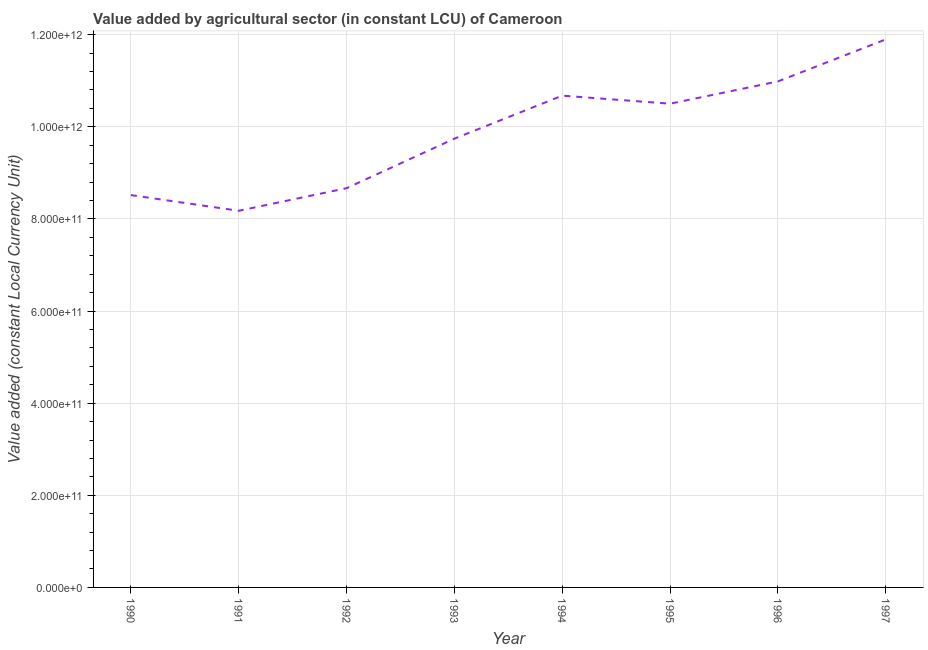What is the value added by agriculture sector in 1993?
Offer a terse response. 9.74e+11. Across all years, what is the maximum value added by agriculture sector?
Your answer should be very brief. 1.19e+12. Across all years, what is the minimum value added by agriculture sector?
Provide a short and direct response. 8.18e+11. In which year was the value added by agriculture sector maximum?
Provide a short and direct response. 1997. What is the sum of the value added by agriculture sector?
Your answer should be compact. 7.92e+12. What is the difference between the value added by agriculture sector in 1995 and 1997?
Keep it short and to the point. -1.40e+11. What is the average value added by agriculture sector per year?
Offer a terse response. 9.89e+11. What is the median value added by agriculture sector?
Your answer should be very brief. 1.01e+12. In how many years, is the value added by agriculture sector greater than 120000000000 LCU?
Ensure brevity in your answer.  8. What is the ratio of the value added by agriculture sector in 1990 to that in 1996?
Keep it short and to the point. 0.78. What is the difference between the highest and the second highest value added by agriculture sector?
Ensure brevity in your answer.  9.12e+1. Is the sum of the value added by agriculture sector in 1996 and 1997 greater than the maximum value added by agriculture sector across all years?
Give a very brief answer. Yes. What is the difference between the highest and the lowest value added by agriculture sector?
Offer a terse response. 3.72e+11. In how many years, is the value added by agriculture sector greater than the average value added by agriculture sector taken over all years?
Give a very brief answer. 4. How many lines are there?
Offer a terse response. 1. How many years are there in the graph?
Offer a very short reply. 8. What is the difference between two consecutive major ticks on the Y-axis?
Your response must be concise. 2.00e+11. Does the graph contain any zero values?
Offer a very short reply. No. Does the graph contain grids?
Give a very brief answer. Yes. What is the title of the graph?
Keep it short and to the point. Value added by agricultural sector (in constant LCU) of Cameroon. What is the label or title of the X-axis?
Your answer should be very brief. Year. What is the label or title of the Y-axis?
Keep it short and to the point. Value added (constant Local Currency Unit). What is the Value added (constant Local Currency Unit) in 1990?
Provide a short and direct response. 8.52e+11. What is the Value added (constant Local Currency Unit) of 1991?
Ensure brevity in your answer.  8.18e+11. What is the Value added (constant Local Currency Unit) of 1992?
Your response must be concise. 8.67e+11. What is the Value added (constant Local Currency Unit) in 1993?
Offer a terse response. 9.74e+11. What is the Value added (constant Local Currency Unit) of 1994?
Provide a succinct answer. 1.07e+12. What is the Value added (constant Local Currency Unit) in 1995?
Make the answer very short. 1.05e+12. What is the Value added (constant Local Currency Unit) of 1996?
Offer a terse response. 1.10e+12. What is the Value added (constant Local Currency Unit) of 1997?
Offer a terse response. 1.19e+12. What is the difference between the Value added (constant Local Currency Unit) in 1990 and 1991?
Give a very brief answer. 3.41e+1. What is the difference between the Value added (constant Local Currency Unit) in 1990 and 1992?
Make the answer very short. -1.50e+1. What is the difference between the Value added (constant Local Currency Unit) in 1990 and 1993?
Make the answer very short. -1.23e+11. What is the difference between the Value added (constant Local Currency Unit) in 1990 and 1994?
Provide a succinct answer. -2.16e+11. What is the difference between the Value added (constant Local Currency Unit) in 1990 and 1995?
Make the answer very short. -1.98e+11. What is the difference between the Value added (constant Local Currency Unit) in 1990 and 1996?
Offer a very short reply. -2.47e+11. What is the difference between the Value added (constant Local Currency Unit) in 1990 and 1997?
Your response must be concise. -3.38e+11. What is the difference between the Value added (constant Local Currency Unit) in 1991 and 1992?
Provide a succinct answer. -4.91e+1. What is the difference between the Value added (constant Local Currency Unit) in 1991 and 1993?
Make the answer very short. -1.57e+11. What is the difference between the Value added (constant Local Currency Unit) in 1991 and 1994?
Make the answer very short. -2.50e+11. What is the difference between the Value added (constant Local Currency Unit) in 1991 and 1995?
Your answer should be very brief. -2.32e+11. What is the difference between the Value added (constant Local Currency Unit) in 1991 and 1996?
Your answer should be compact. -2.81e+11. What is the difference between the Value added (constant Local Currency Unit) in 1991 and 1997?
Your response must be concise. -3.72e+11. What is the difference between the Value added (constant Local Currency Unit) in 1992 and 1993?
Make the answer very short. -1.08e+11. What is the difference between the Value added (constant Local Currency Unit) in 1992 and 1994?
Make the answer very short. -2.01e+11. What is the difference between the Value added (constant Local Currency Unit) in 1992 and 1995?
Provide a short and direct response. -1.83e+11. What is the difference between the Value added (constant Local Currency Unit) in 1992 and 1996?
Make the answer very short. -2.32e+11. What is the difference between the Value added (constant Local Currency Unit) in 1992 and 1997?
Your answer should be very brief. -3.23e+11. What is the difference between the Value added (constant Local Currency Unit) in 1993 and 1994?
Your answer should be compact. -9.33e+1. What is the difference between the Value added (constant Local Currency Unit) in 1993 and 1995?
Your response must be concise. -7.59e+1. What is the difference between the Value added (constant Local Currency Unit) in 1993 and 1996?
Ensure brevity in your answer.  -1.24e+11. What is the difference between the Value added (constant Local Currency Unit) in 1993 and 1997?
Offer a terse response. -2.15e+11. What is the difference between the Value added (constant Local Currency Unit) in 1994 and 1995?
Your response must be concise. 1.75e+1. What is the difference between the Value added (constant Local Currency Unit) in 1994 and 1996?
Make the answer very short. -3.09e+1. What is the difference between the Value added (constant Local Currency Unit) in 1994 and 1997?
Provide a short and direct response. -1.22e+11. What is the difference between the Value added (constant Local Currency Unit) in 1995 and 1996?
Provide a short and direct response. -4.84e+1. What is the difference between the Value added (constant Local Currency Unit) in 1995 and 1997?
Give a very brief answer. -1.40e+11. What is the difference between the Value added (constant Local Currency Unit) in 1996 and 1997?
Your answer should be very brief. -9.12e+1. What is the ratio of the Value added (constant Local Currency Unit) in 1990 to that in 1991?
Your response must be concise. 1.04. What is the ratio of the Value added (constant Local Currency Unit) in 1990 to that in 1992?
Offer a terse response. 0.98. What is the ratio of the Value added (constant Local Currency Unit) in 1990 to that in 1993?
Your response must be concise. 0.87. What is the ratio of the Value added (constant Local Currency Unit) in 1990 to that in 1994?
Give a very brief answer. 0.8. What is the ratio of the Value added (constant Local Currency Unit) in 1990 to that in 1995?
Offer a terse response. 0.81. What is the ratio of the Value added (constant Local Currency Unit) in 1990 to that in 1996?
Offer a terse response. 0.78. What is the ratio of the Value added (constant Local Currency Unit) in 1990 to that in 1997?
Give a very brief answer. 0.72. What is the ratio of the Value added (constant Local Currency Unit) in 1991 to that in 1992?
Your answer should be compact. 0.94. What is the ratio of the Value added (constant Local Currency Unit) in 1991 to that in 1993?
Offer a terse response. 0.84. What is the ratio of the Value added (constant Local Currency Unit) in 1991 to that in 1994?
Your answer should be very brief. 0.77. What is the ratio of the Value added (constant Local Currency Unit) in 1991 to that in 1995?
Make the answer very short. 0.78. What is the ratio of the Value added (constant Local Currency Unit) in 1991 to that in 1996?
Provide a short and direct response. 0.74. What is the ratio of the Value added (constant Local Currency Unit) in 1991 to that in 1997?
Make the answer very short. 0.69. What is the ratio of the Value added (constant Local Currency Unit) in 1992 to that in 1993?
Keep it short and to the point. 0.89. What is the ratio of the Value added (constant Local Currency Unit) in 1992 to that in 1994?
Provide a short and direct response. 0.81. What is the ratio of the Value added (constant Local Currency Unit) in 1992 to that in 1995?
Ensure brevity in your answer.  0.82. What is the ratio of the Value added (constant Local Currency Unit) in 1992 to that in 1996?
Keep it short and to the point. 0.79. What is the ratio of the Value added (constant Local Currency Unit) in 1992 to that in 1997?
Ensure brevity in your answer.  0.73. What is the ratio of the Value added (constant Local Currency Unit) in 1993 to that in 1995?
Provide a succinct answer. 0.93. What is the ratio of the Value added (constant Local Currency Unit) in 1993 to that in 1996?
Ensure brevity in your answer.  0.89. What is the ratio of the Value added (constant Local Currency Unit) in 1993 to that in 1997?
Provide a succinct answer. 0.82. What is the ratio of the Value added (constant Local Currency Unit) in 1994 to that in 1995?
Provide a short and direct response. 1.02. What is the ratio of the Value added (constant Local Currency Unit) in 1994 to that in 1996?
Your answer should be compact. 0.97. What is the ratio of the Value added (constant Local Currency Unit) in 1994 to that in 1997?
Offer a very short reply. 0.9. What is the ratio of the Value added (constant Local Currency Unit) in 1995 to that in 1996?
Keep it short and to the point. 0.96. What is the ratio of the Value added (constant Local Currency Unit) in 1995 to that in 1997?
Your answer should be compact. 0.88. What is the ratio of the Value added (constant Local Currency Unit) in 1996 to that in 1997?
Provide a short and direct response. 0.92. 